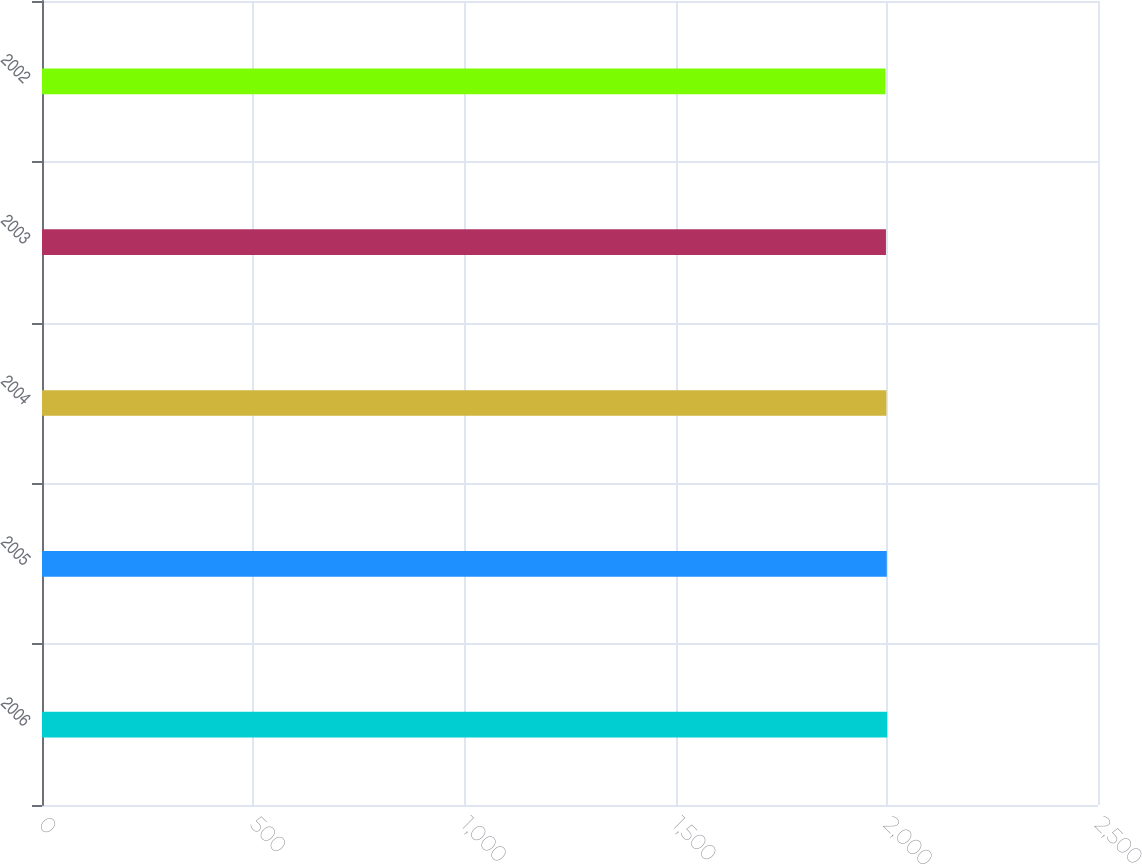<chart> <loc_0><loc_0><loc_500><loc_500><bar_chart><fcel>2006<fcel>2005<fcel>2004<fcel>2003<fcel>2002<nl><fcel>2001<fcel>2000<fcel>1999<fcel>1998<fcel>1997<nl></chart> 